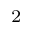Convert formula to latex. <formula><loc_0><loc_0><loc_500><loc_500>^ { 2 }</formula> 